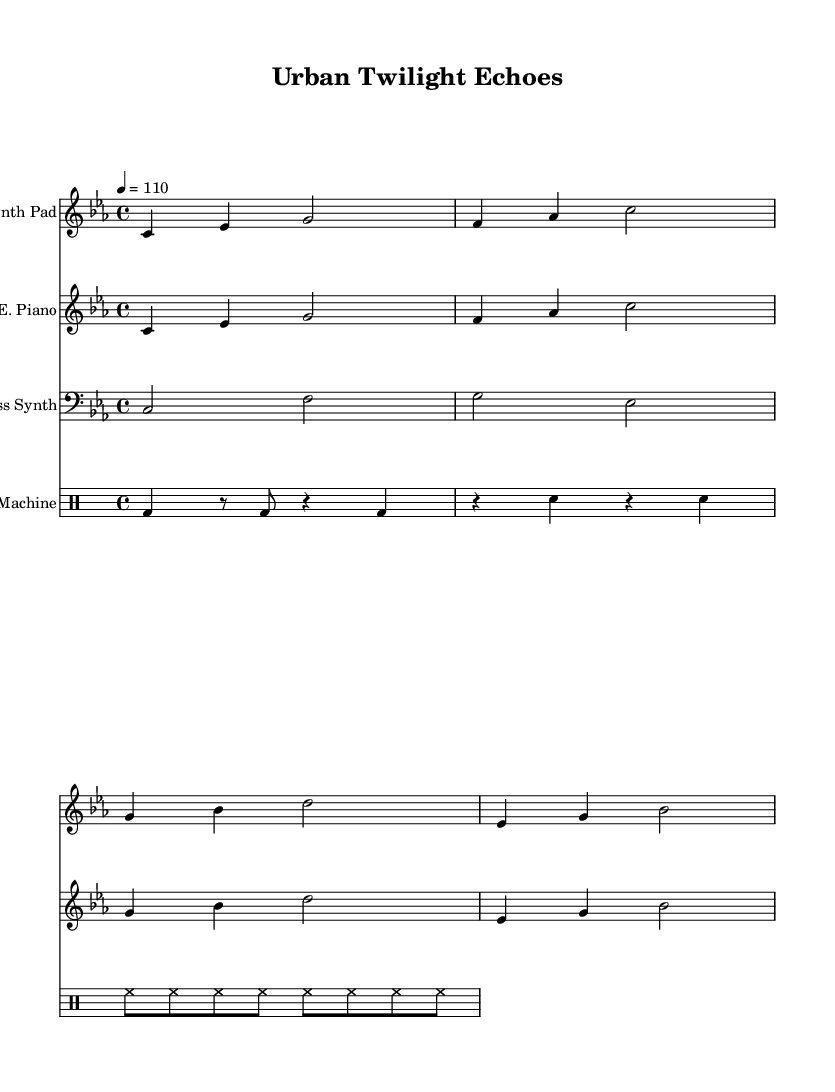What is the key signature of this music? The key signature is C minor, which contains three flats (B, E, and A). In the music sheet, the flat symbols before the notes indicate the tonality is based on C minor.
Answer: C minor What is the time signature indicated in the music? The time signature is indicated at the beginning of the sheet music as 4/4, meaning there are four beats in each measure and a quarter note gets one beat.
Answer: 4/4 What is the tempo marking of the piece? The tempo marking is indicated as "4 = 110" at the beginning of the score, recommending a speed of 110 beats per minute for the quarter note.
Answer: 110 How many instruments are scored in this piece? The score lists four distinct parts: Synth Pad, Electric Piano, Bass Synth, and Drum Machine, which are played simultaneously to create the ambient sound.
Answer: Four Which instrument plays a bass line? The bass line is represented by the "Bass Synth" staff, which uses lower notes (clef bass) suited for bass sounds.
Answer: Bass Synth What rhythmic style is used in the drum machine part? The drum machine part includes a combination of bass drum, snare, and hi-hat patterns, creating a driving rhythmic style typical for dance music.
Answer: Driving rhythmic style Which section contains the highest pitches? The "Synth Pad" and "Electric Piano" sections contain the highest pitches, as both are written in treble clef and have no lower notes compared to the Bass Synth.
Answer: Synth Pad and Electric Piano 